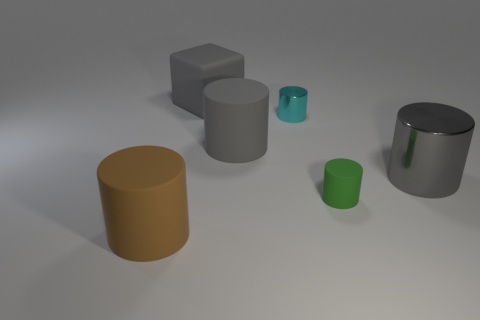Is the rubber block the same color as the large metallic object?
Give a very brief answer. Yes. Is there a brown block of the same size as the brown rubber thing?
Ensure brevity in your answer.  No. There is another cylinder that is made of the same material as the cyan cylinder; what is its size?
Your response must be concise. Large. What is the shape of the green matte object?
Offer a very short reply. Cylinder. Does the big block have the same material as the big cylinder that is left of the big gray rubber block?
Make the answer very short. Yes. What number of objects are either big metal objects or cyan objects?
Your answer should be very brief. 2. Is there a tiny brown sphere?
Provide a short and direct response. No. There is a gray rubber thing behind the gray cylinder to the left of the large metal thing; what shape is it?
Your answer should be compact. Cube. How many things are either cylinders in front of the small cyan metallic thing or objects behind the tiny cyan cylinder?
Ensure brevity in your answer.  5. There is a brown cylinder that is the same size as the gray rubber cylinder; what material is it?
Provide a short and direct response. Rubber. 